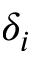Convert formula to latex. <formula><loc_0><loc_0><loc_500><loc_500>\delta _ { i }</formula> 